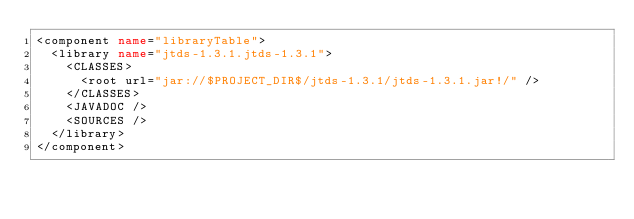Convert code to text. <code><loc_0><loc_0><loc_500><loc_500><_XML_><component name="libraryTable">
  <library name="jtds-1.3.1.jtds-1.3.1">
    <CLASSES>
      <root url="jar://$PROJECT_DIR$/jtds-1.3.1/jtds-1.3.1.jar!/" />
    </CLASSES>
    <JAVADOC />
    <SOURCES />
  </library>
</component></code> 